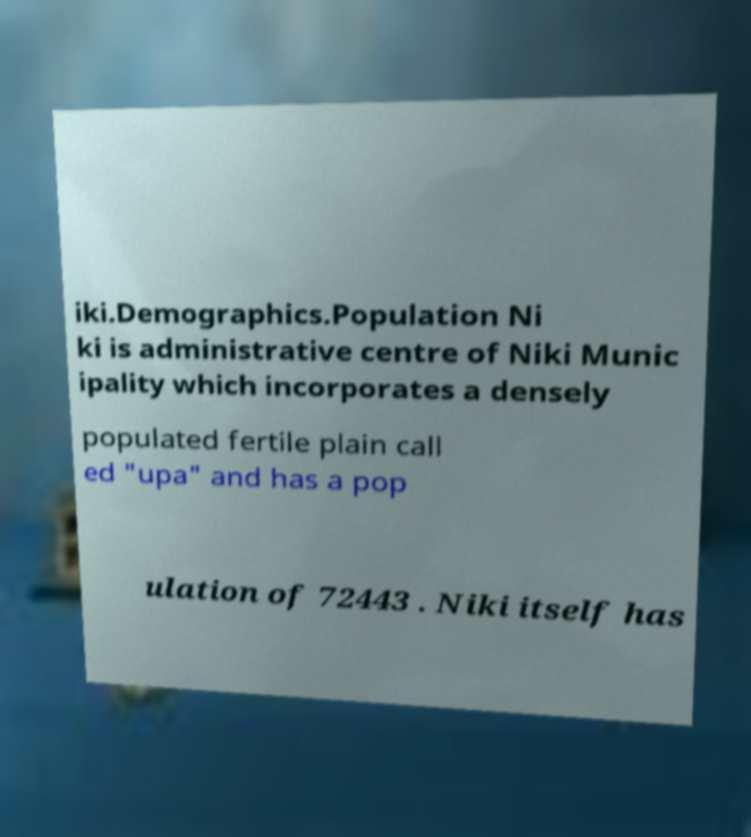Can you read and provide the text displayed in the image?This photo seems to have some interesting text. Can you extract and type it out for me? iki.Demographics.Population Ni ki is administrative centre of Niki Munic ipality which incorporates a densely populated fertile plain call ed "upa" and has a pop ulation of 72443 . Niki itself has 